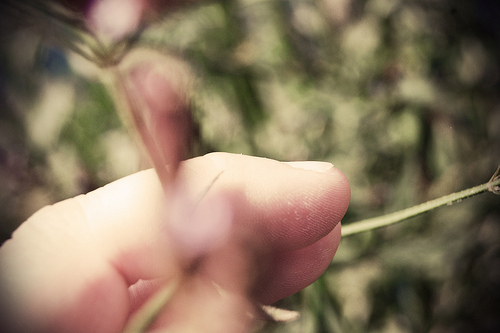<image>
Is the finger on the leaf? Yes. Looking at the image, I can see the finger is positioned on top of the leaf, with the leaf providing support. 